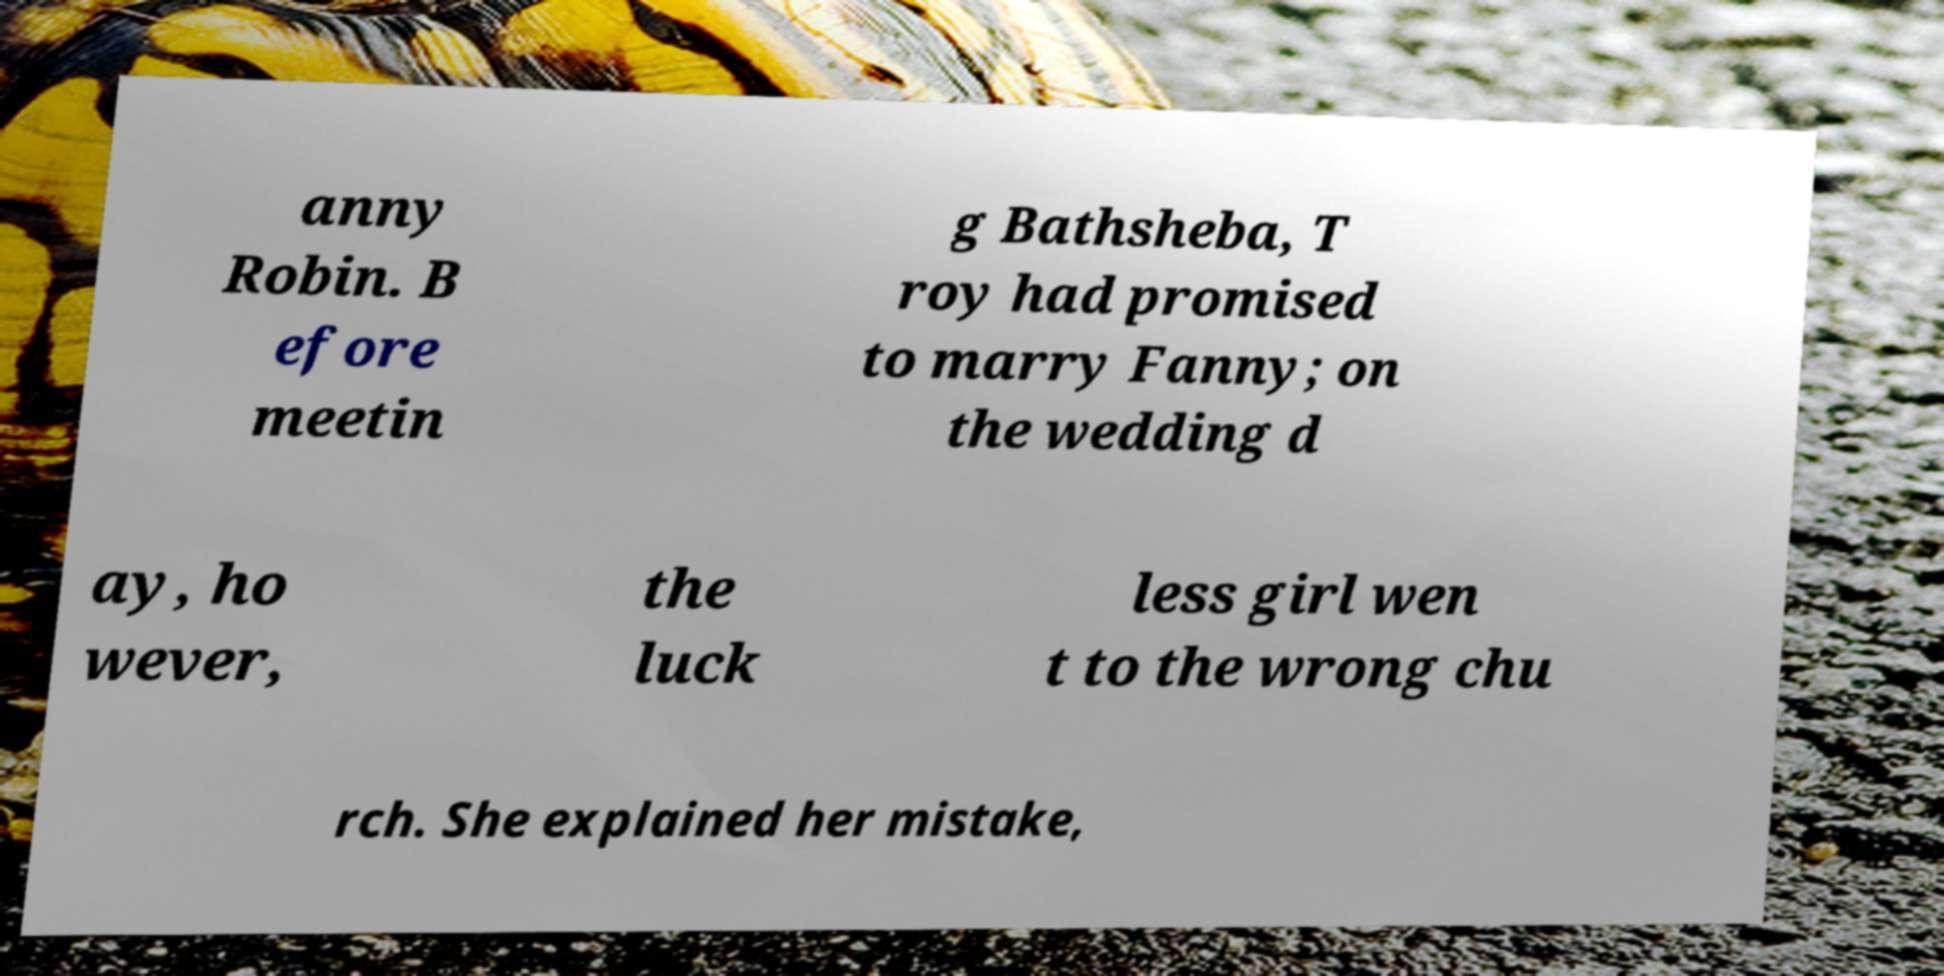Can you accurately transcribe the text from the provided image for me? anny Robin. B efore meetin g Bathsheba, T roy had promised to marry Fanny; on the wedding d ay, ho wever, the luck less girl wen t to the wrong chu rch. She explained her mistake, 